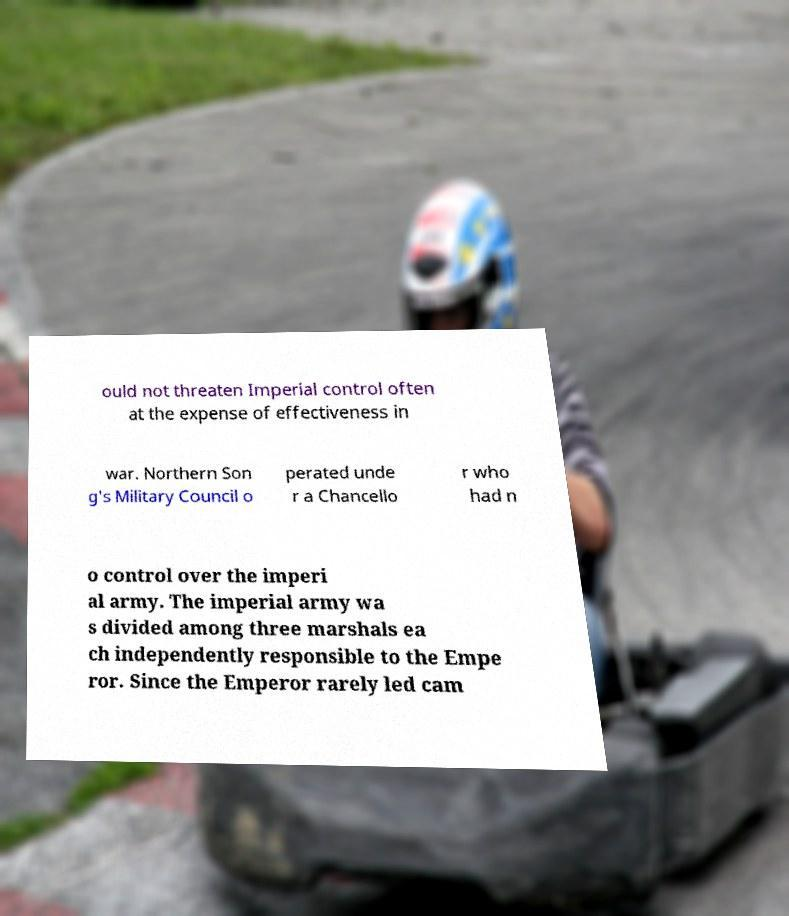Can you accurately transcribe the text from the provided image for me? ould not threaten Imperial control often at the expense of effectiveness in war. Northern Son g's Military Council o perated unde r a Chancello r who had n o control over the imperi al army. The imperial army wa s divided among three marshals ea ch independently responsible to the Empe ror. Since the Emperor rarely led cam 